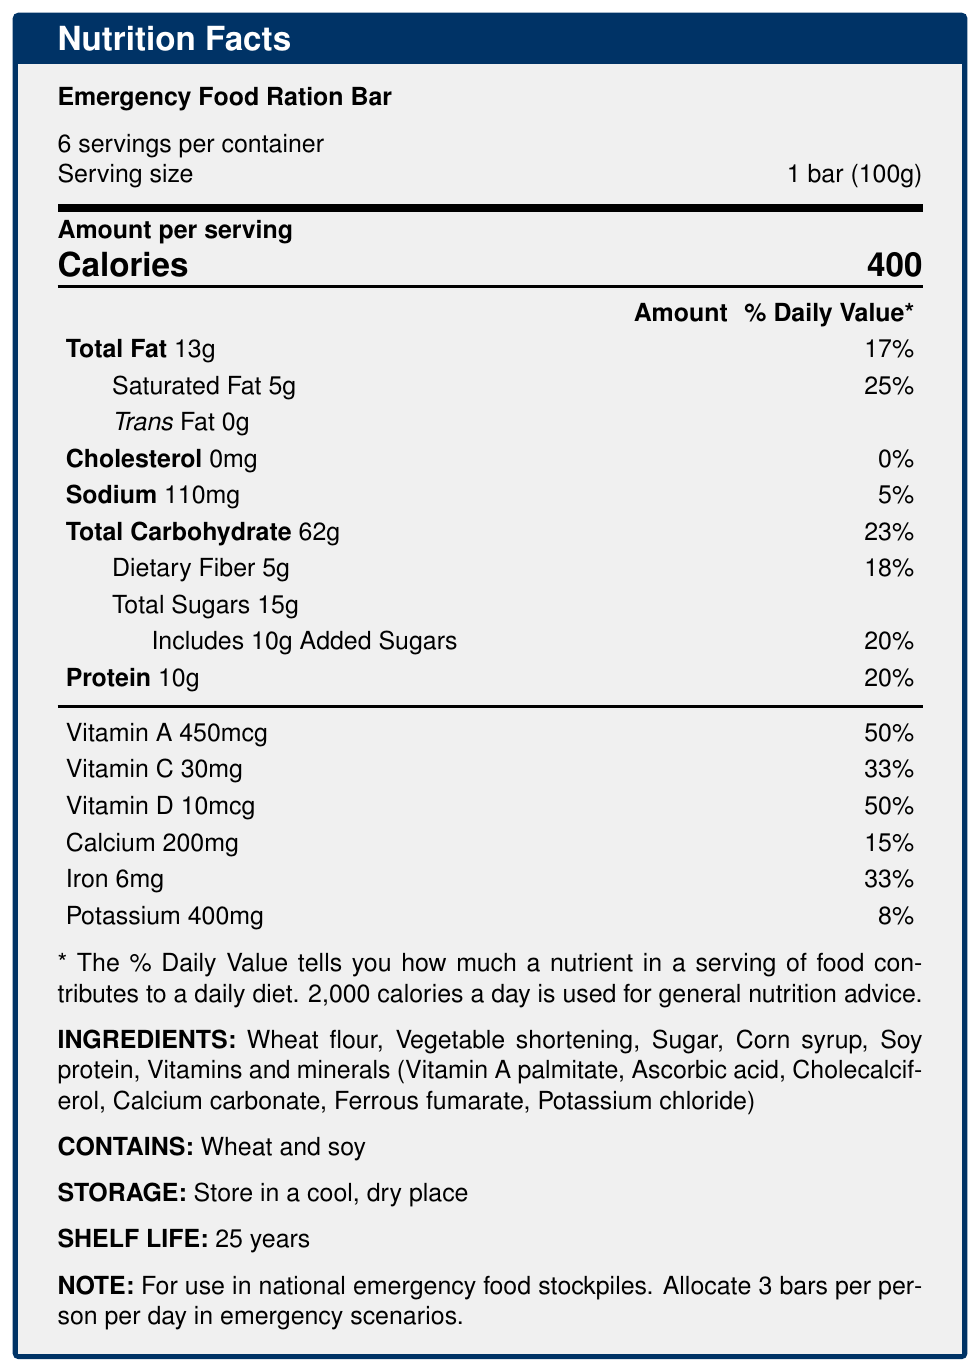What is the serving size of the Emergency Food Ration Bar? The document states, "Serving size: 1 bar (100g)".
Answer: 1 bar (100g) How many servings are there per container? The document mentions, "6 servings per container".
Answer: 6 What is the total fat content per serving? Under the "Amount per serving" section, it states, "Total Fat: 13g".
Answer: 13 grams Does the Emergency Food Ration Bar contain cholesterol? The document lists "Cholesterol: 0mg", indicating there is no cholesterol.
Answer: No What percentage of the daily value of iron does one serving provide? The document states under "Iron: 6mg" that the daily value percentage is 33%.
Answer: 33% How long is the shelf life of the Emergency Food Ration Bar? The document mentions, "Shelf Life: 25 years".
Answer: 25 years What type of allergens does the Emergency Food Ration Bar contain? The document lists under "CONTAINS:", "Wheat and soy".
Answer: Wheat and soy How many calories are in one serving of the Emergency Food Ration Bar? A. 300 B. 350 C. 400 D. 450 The document clearly states "Calories: 400" under "Amount per serving".
Answer: C: 400 What is the recommended daily allocation per person in an emergency scenario? A. 1 bar B. 2 bars C. 3 bars D. 4 bars The document mentions in "NOTE: For use in national emergency food stockpiles. Allocate 3 bars per person per day in emergency scenarios".
Answer: C: 3 bars Which vitamin is present in the highest daily value percentage per serving? A. Vitamin A B. Vitamin C C. Vitamin D D. Iron Vitamin A has a daily value percentage of 50%, which is the highest.
Answer: A: Vitamin A Is there any trans fat in the Emergency Food Ration Bar? The document lists "Trans Fat: 0g", indicating there is no trans fat.
Answer: No Summarize the main nutritional information and storage conditions of the Emergency Food Ration Bar. The document provides detailed nutritional facts, including calorie content and the amount of various nutrients per serving. It also includes shelf life, storage instructions, allergen information, and its intended use for emergency scenarios.
Answer: The Emergency Food Ration Bar contains 400 calories per serving, with 13g of total fat, 5g of saturated fat, 0g of trans fat, 0mg of cholesterol, 110mg of sodium, 62g of total carbohydrates, 5g of dietary fiber, 15g of total sugars (including 10g of added sugars), and 10g of protein. It also provides significant amounts of Vitamin A, Vitamin C, Vitamin D, calcium, iron, and potassium. It has a long shelf life of 25 years and should be stored in a cool, dry place. It contains wheat and soy allergens and is designed for national emergency stockpiles. Recommended usage is 3 bars per person per day. What is the proportion of calories from protein in one bar? The document does not provide the specific calorie content from protein, only the amount in grams.
Answer: Not enough information What is the main purpose of the Emergency Food Ration Bar as stated in the document? The document states that its purpose is "For use in national emergency food stockpiles".
Answer: For use in national emergency food stockpiles What are the key benefits of the Emergency Food Ration Bar? The document lists these key benefits: "Long shelf life, Compact and lightweight, Nutritionally complete, No preparation required".
Answer: Long shelf life, compact and lightweight, nutritionally complete, no preparation required What vitamin contributes to 50% of the daily value per serving and what is its amount in micrograms? The document lists both Vitamin A (450 mcg) and Vitamin D (10 mcg) each at 50% of the daily value per serving.
Answer: Vitamin A, 450 micrograms; Vitamin D, 10 micrograms 